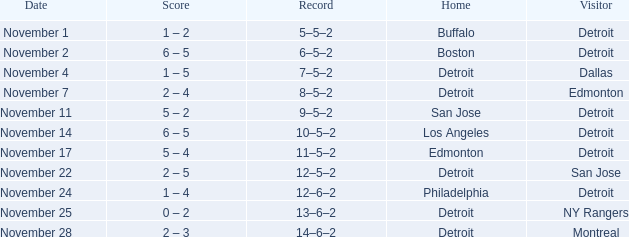Which visitor has a Los Angeles home? Detroit. 